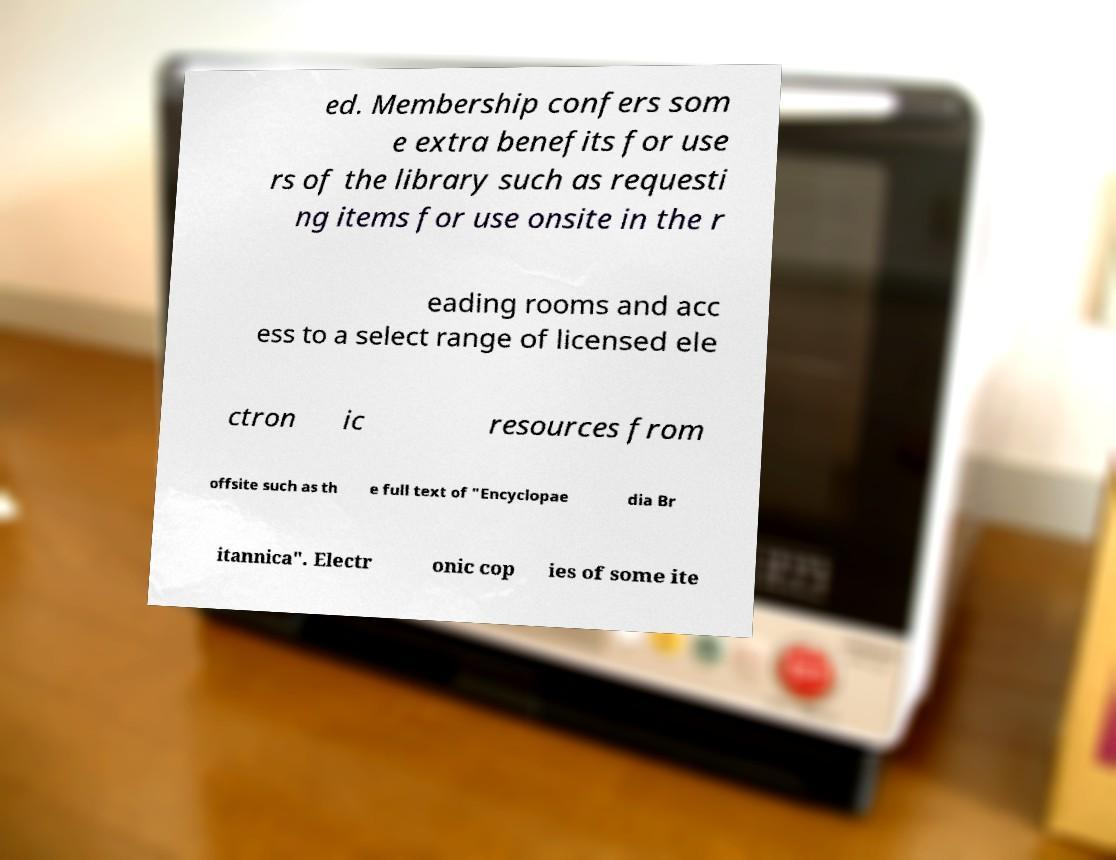Can you read and provide the text displayed in the image?This photo seems to have some interesting text. Can you extract and type it out for me? ed. Membership confers som e extra benefits for use rs of the library such as requesti ng items for use onsite in the r eading rooms and acc ess to a select range of licensed ele ctron ic resources from offsite such as th e full text of "Encyclopae dia Br itannica". Electr onic cop ies of some ite 